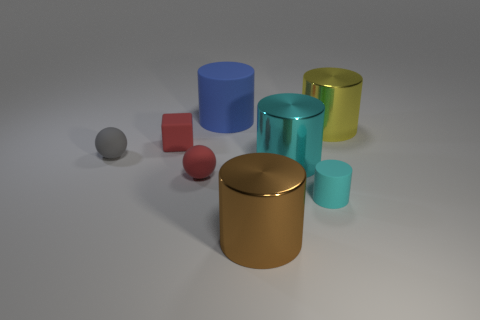What shape is the matte thing that is the same color as the rubber cube?
Ensure brevity in your answer.  Sphere. Is there any other thing of the same color as the tiny cylinder?
Make the answer very short. Yes. The blue rubber object that is the same size as the yellow cylinder is what shape?
Keep it short and to the point. Cylinder. There is a object that is the same color as the tiny block; what is its material?
Your answer should be compact. Rubber. There is a red object to the right of the matte cube; what material is it?
Provide a succinct answer. Rubber. Are there any other things that are the same size as the brown thing?
Your answer should be compact. Yes. Are there any gray rubber spheres behind the large matte cylinder?
Provide a succinct answer. No. The tiny gray thing is what shape?
Give a very brief answer. Sphere. What number of things are rubber things in front of the yellow shiny thing or yellow matte balls?
Offer a terse response. 4. What number of other things are there of the same color as the big rubber object?
Offer a very short reply. 0. 